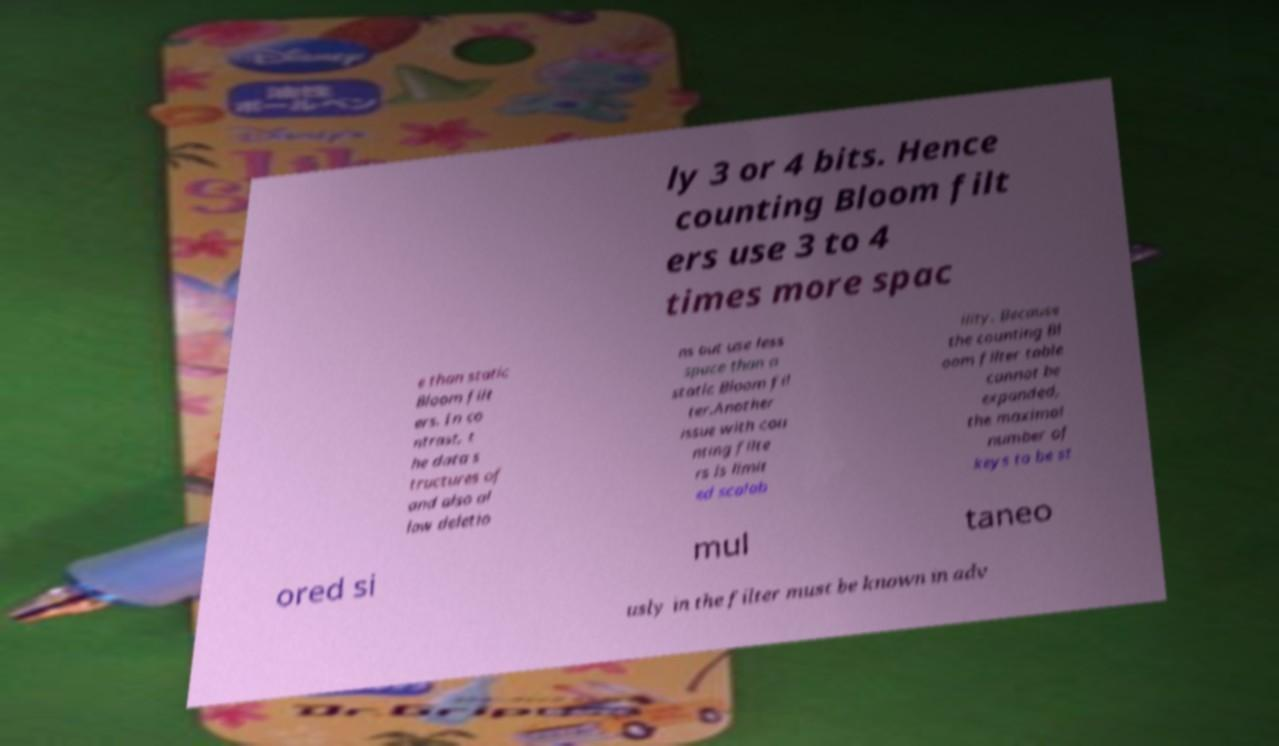Can you accurately transcribe the text from the provided image for me? ly 3 or 4 bits. Hence counting Bloom filt ers use 3 to 4 times more spac e than static Bloom filt ers. In co ntrast, t he data s tructures of and also al low deletio ns but use less space than a static Bloom fil ter.Another issue with cou nting filte rs is limit ed scalab ility. Because the counting Bl oom filter table cannot be expanded, the maximal number of keys to be st ored si mul taneo usly in the filter must be known in adv 